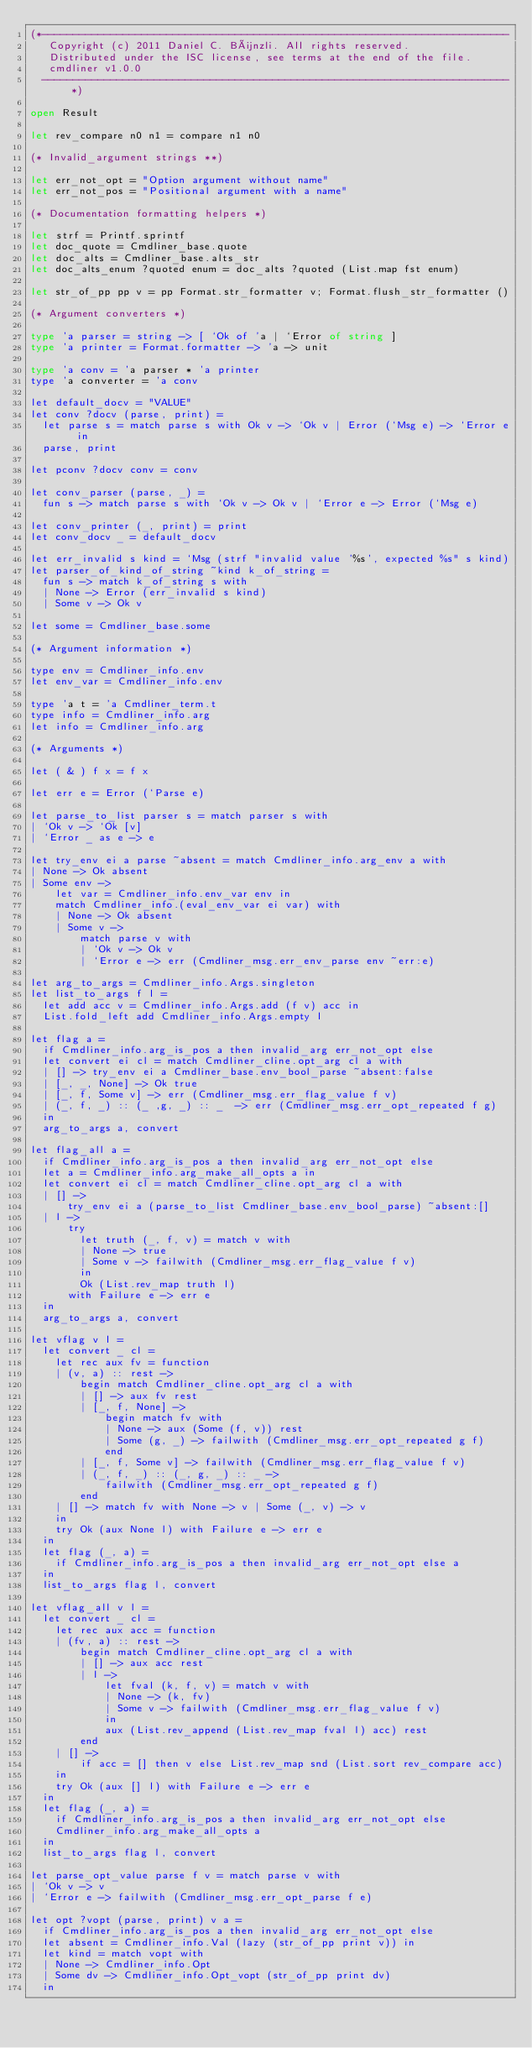<code> <loc_0><loc_0><loc_500><loc_500><_OCaml_>(*---------------------------------------------------------------------------
   Copyright (c) 2011 Daniel C. Bünzli. All rights reserved.
   Distributed under the ISC license, see terms at the end of the file.
   cmdliner v1.0.0
  ---------------------------------------------------------------------------*)

open Result

let rev_compare n0 n1 = compare n1 n0

(* Invalid_argument strings **)

let err_not_opt = "Option argument without name"
let err_not_pos = "Positional argument with a name"

(* Documentation formatting helpers *)

let strf = Printf.sprintf
let doc_quote = Cmdliner_base.quote
let doc_alts = Cmdliner_base.alts_str
let doc_alts_enum ?quoted enum = doc_alts ?quoted (List.map fst enum)

let str_of_pp pp v = pp Format.str_formatter v; Format.flush_str_formatter ()

(* Argument converters *)

type 'a parser = string -> [ `Ok of 'a | `Error of string ]
type 'a printer = Format.formatter -> 'a -> unit

type 'a conv = 'a parser * 'a printer
type 'a converter = 'a conv

let default_docv = "VALUE"
let conv ?docv (parse, print) =
  let parse s = match parse s with Ok v -> `Ok v | Error (`Msg e) -> `Error e in
  parse, print

let pconv ?docv conv = conv

let conv_parser (parse, _) =
  fun s -> match parse s with `Ok v -> Ok v | `Error e -> Error (`Msg e)

let conv_printer (_, print) = print
let conv_docv _ = default_docv

let err_invalid s kind = `Msg (strf "invalid value '%s', expected %s" s kind)
let parser_of_kind_of_string ~kind k_of_string =
  fun s -> match k_of_string s with
  | None -> Error (err_invalid s kind)
  | Some v -> Ok v

let some = Cmdliner_base.some

(* Argument information *)

type env = Cmdliner_info.env
let env_var = Cmdliner_info.env

type 'a t = 'a Cmdliner_term.t
type info = Cmdliner_info.arg
let info = Cmdliner_info.arg

(* Arguments *)

let ( & ) f x = f x

let err e = Error (`Parse e)

let parse_to_list parser s = match parser s with
| `Ok v -> `Ok [v]
| `Error _ as e -> e

let try_env ei a parse ~absent = match Cmdliner_info.arg_env a with
| None -> Ok absent
| Some env ->
    let var = Cmdliner_info.env_var env in
    match Cmdliner_info.(eval_env_var ei var) with
    | None -> Ok absent
    | Some v ->
        match parse v with
        | `Ok v -> Ok v
        | `Error e -> err (Cmdliner_msg.err_env_parse env ~err:e)

let arg_to_args = Cmdliner_info.Args.singleton
let list_to_args f l =
  let add acc v = Cmdliner_info.Args.add (f v) acc in
  List.fold_left add Cmdliner_info.Args.empty l

let flag a =
  if Cmdliner_info.arg_is_pos a then invalid_arg err_not_opt else
  let convert ei cl = match Cmdliner_cline.opt_arg cl a with
  | [] -> try_env ei a Cmdliner_base.env_bool_parse ~absent:false
  | [_, _, None] -> Ok true
  | [_, f, Some v] -> err (Cmdliner_msg.err_flag_value f v)
  | (_, f, _) :: (_ ,g, _) :: _  -> err (Cmdliner_msg.err_opt_repeated f g)
  in
  arg_to_args a, convert

let flag_all a =
  if Cmdliner_info.arg_is_pos a then invalid_arg err_not_opt else
  let a = Cmdliner_info.arg_make_all_opts a in
  let convert ei cl = match Cmdliner_cline.opt_arg cl a with
  | [] ->
      try_env ei a (parse_to_list Cmdliner_base.env_bool_parse) ~absent:[]
  | l ->
      try
        let truth (_, f, v) = match v with
        | None -> true
        | Some v -> failwith (Cmdliner_msg.err_flag_value f v)
        in
        Ok (List.rev_map truth l)
      with Failure e -> err e
  in
  arg_to_args a, convert

let vflag v l =
  let convert _ cl =
    let rec aux fv = function
    | (v, a) :: rest ->
        begin match Cmdliner_cline.opt_arg cl a with
        | [] -> aux fv rest
        | [_, f, None] ->
            begin match fv with
            | None -> aux (Some (f, v)) rest
            | Some (g, _) -> failwith (Cmdliner_msg.err_opt_repeated g f)
            end
        | [_, f, Some v] -> failwith (Cmdliner_msg.err_flag_value f v)
        | (_, f, _) :: (_, g, _) :: _ ->
            failwith (Cmdliner_msg.err_opt_repeated g f)
        end
    | [] -> match fv with None -> v | Some (_, v) -> v
    in
    try Ok (aux None l) with Failure e -> err e
  in
  let flag (_, a) =
    if Cmdliner_info.arg_is_pos a then invalid_arg err_not_opt else a
  in
  list_to_args flag l, convert

let vflag_all v l =
  let convert _ cl =
    let rec aux acc = function
    | (fv, a) :: rest ->
        begin match Cmdliner_cline.opt_arg cl a with
        | [] -> aux acc rest
        | l ->
            let fval (k, f, v) = match v with
            | None -> (k, fv)
            | Some v -> failwith (Cmdliner_msg.err_flag_value f v)
            in
            aux (List.rev_append (List.rev_map fval l) acc) rest
        end
    | [] ->
        if acc = [] then v else List.rev_map snd (List.sort rev_compare acc)
    in
    try Ok (aux [] l) with Failure e -> err e
  in
  let flag (_, a) =
    if Cmdliner_info.arg_is_pos a then invalid_arg err_not_opt else
    Cmdliner_info.arg_make_all_opts a
  in
  list_to_args flag l, convert

let parse_opt_value parse f v = match parse v with
| `Ok v -> v
| `Error e -> failwith (Cmdliner_msg.err_opt_parse f e)

let opt ?vopt (parse, print) v a =
  if Cmdliner_info.arg_is_pos a then invalid_arg err_not_opt else
  let absent = Cmdliner_info.Val (lazy (str_of_pp print v)) in
  let kind = match vopt with
  | None -> Cmdliner_info.Opt
  | Some dv -> Cmdliner_info.Opt_vopt (str_of_pp print dv)
  in</code> 